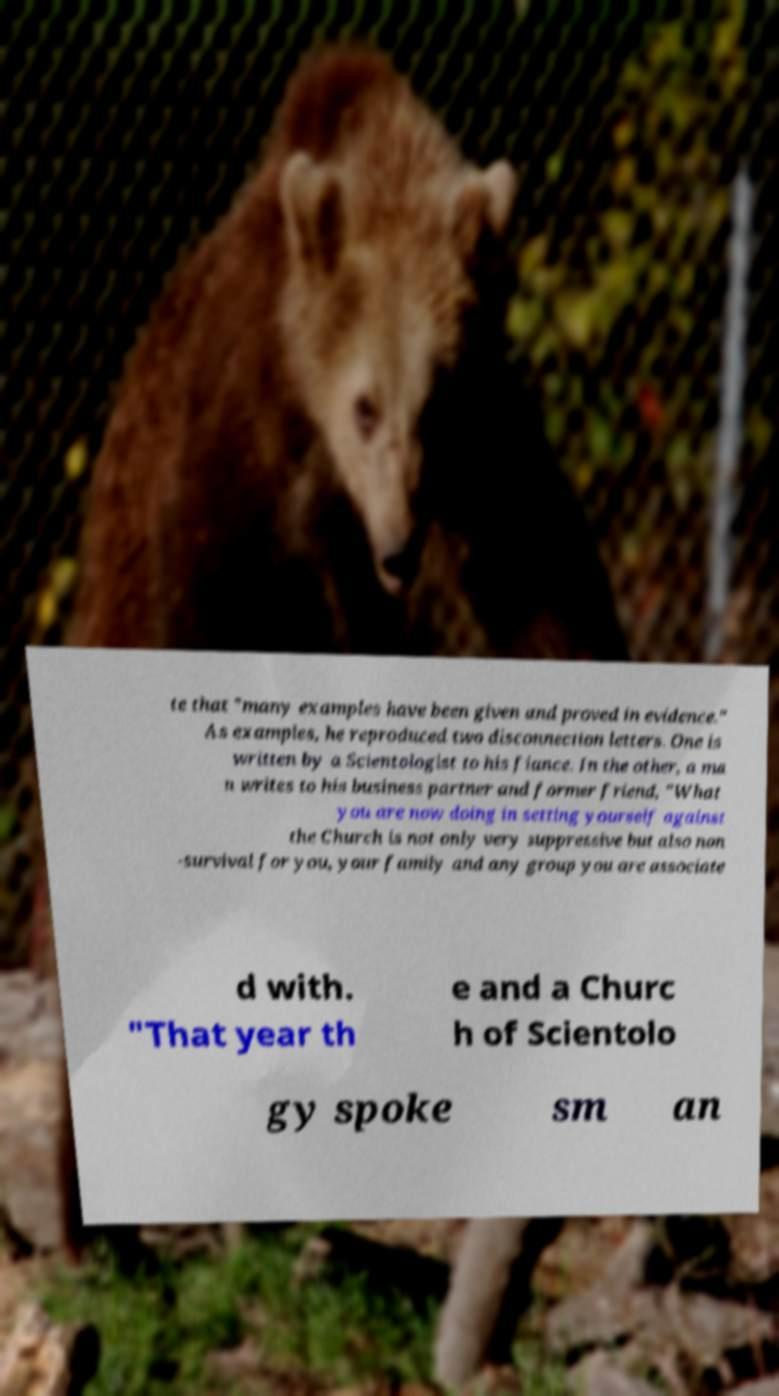There's text embedded in this image that I need extracted. Can you transcribe it verbatim? te that "many examples have been given and proved in evidence." As examples, he reproduced two disconnection letters. One is written by a Scientologist to his fiance. In the other, a ma n writes to his business partner and former friend, "What you are now doing in setting yourself against the Church is not only very suppressive but also non -survival for you, your family and any group you are associate d with. "That year th e and a Churc h of Scientolo gy spoke sm an 